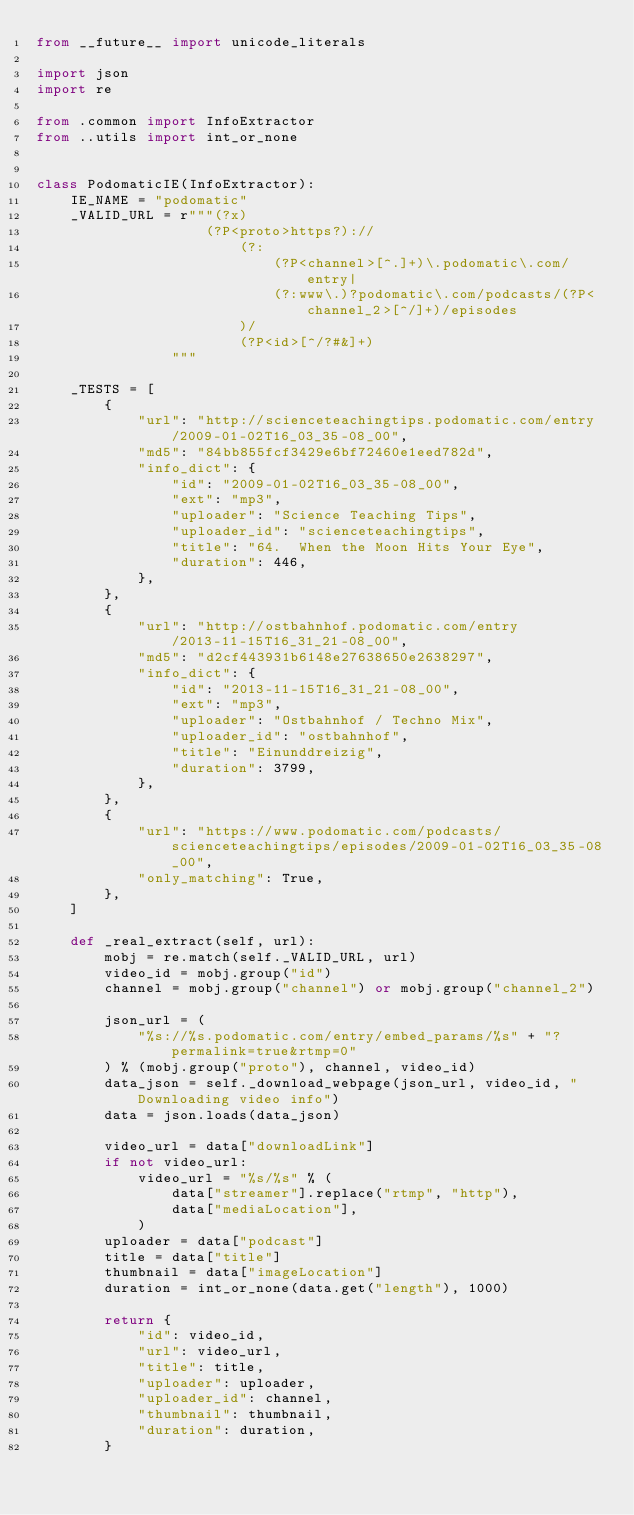<code> <loc_0><loc_0><loc_500><loc_500><_Python_>from __future__ import unicode_literals

import json
import re

from .common import InfoExtractor
from ..utils import int_or_none


class PodomaticIE(InfoExtractor):
    IE_NAME = "podomatic"
    _VALID_URL = r"""(?x)
                    (?P<proto>https?)://
                        (?:
                            (?P<channel>[^.]+)\.podomatic\.com/entry|
                            (?:www\.)?podomatic\.com/podcasts/(?P<channel_2>[^/]+)/episodes
                        )/
                        (?P<id>[^/?#&]+)
                """

    _TESTS = [
        {
            "url": "http://scienceteachingtips.podomatic.com/entry/2009-01-02T16_03_35-08_00",
            "md5": "84bb855fcf3429e6bf72460e1eed782d",
            "info_dict": {
                "id": "2009-01-02T16_03_35-08_00",
                "ext": "mp3",
                "uploader": "Science Teaching Tips",
                "uploader_id": "scienceteachingtips",
                "title": "64.  When the Moon Hits Your Eye",
                "duration": 446,
            },
        },
        {
            "url": "http://ostbahnhof.podomatic.com/entry/2013-11-15T16_31_21-08_00",
            "md5": "d2cf443931b6148e27638650e2638297",
            "info_dict": {
                "id": "2013-11-15T16_31_21-08_00",
                "ext": "mp3",
                "uploader": "Ostbahnhof / Techno Mix",
                "uploader_id": "ostbahnhof",
                "title": "Einunddreizig",
                "duration": 3799,
            },
        },
        {
            "url": "https://www.podomatic.com/podcasts/scienceteachingtips/episodes/2009-01-02T16_03_35-08_00",
            "only_matching": True,
        },
    ]

    def _real_extract(self, url):
        mobj = re.match(self._VALID_URL, url)
        video_id = mobj.group("id")
        channel = mobj.group("channel") or mobj.group("channel_2")

        json_url = (
            "%s://%s.podomatic.com/entry/embed_params/%s" + "?permalink=true&rtmp=0"
        ) % (mobj.group("proto"), channel, video_id)
        data_json = self._download_webpage(json_url, video_id, "Downloading video info")
        data = json.loads(data_json)

        video_url = data["downloadLink"]
        if not video_url:
            video_url = "%s/%s" % (
                data["streamer"].replace("rtmp", "http"),
                data["mediaLocation"],
            )
        uploader = data["podcast"]
        title = data["title"]
        thumbnail = data["imageLocation"]
        duration = int_or_none(data.get("length"), 1000)

        return {
            "id": video_id,
            "url": video_url,
            "title": title,
            "uploader": uploader,
            "uploader_id": channel,
            "thumbnail": thumbnail,
            "duration": duration,
        }
</code> 